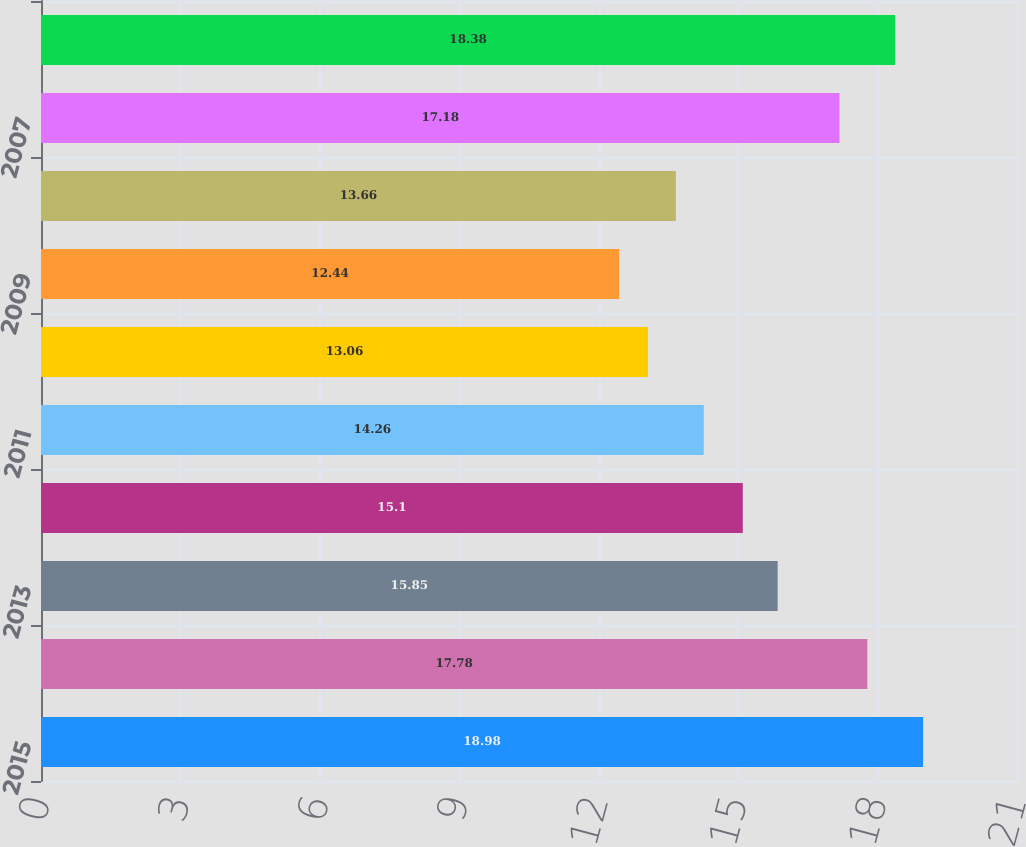<chart> <loc_0><loc_0><loc_500><loc_500><bar_chart><fcel>2015<fcel>2014<fcel>2013<fcel>2012<fcel>2011<fcel>2010<fcel>2009<fcel>2008<fcel>2007<fcel>2006<nl><fcel>18.98<fcel>17.78<fcel>15.85<fcel>15.1<fcel>14.26<fcel>13.06<fcel>12.44<fcel>13.66<fcel>17.18<fcel>18.38<nl></chart> 